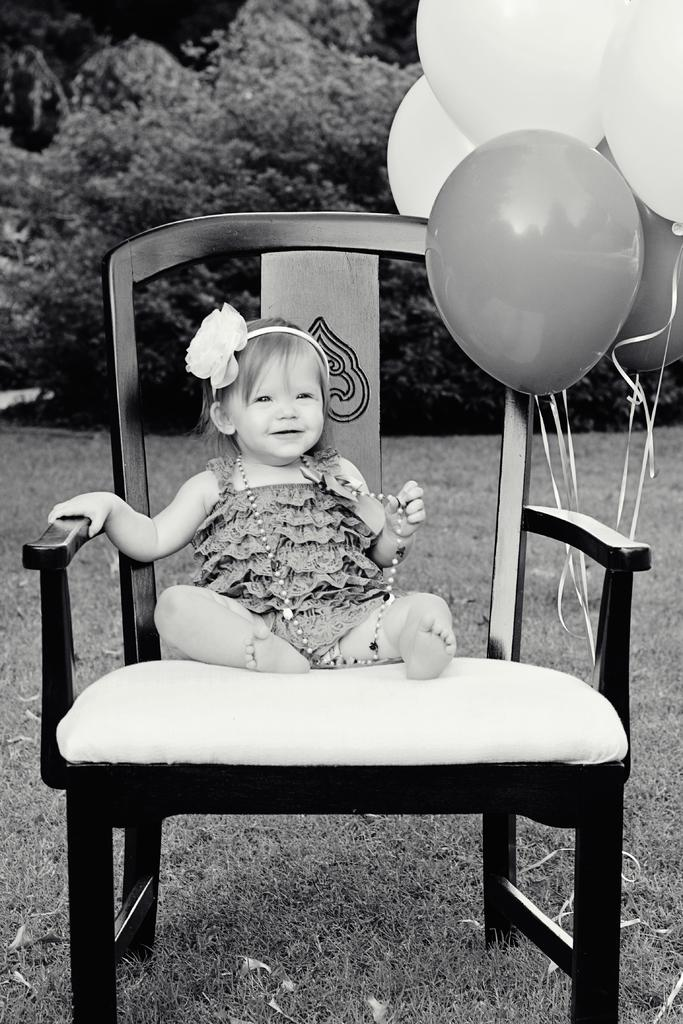What is the main subject of the image? There is a baby in the image. Where is the baby sitting? The baby is sitting on a chair. What is attached to the chair? Balloons are tied to the chair. What can be seen in the background of the image? There are plants in the background of the image. What type of flooring is visible in the image? The floor is made of grass. What type of cord is the baby holding in the image? There is no cord present in the image. 